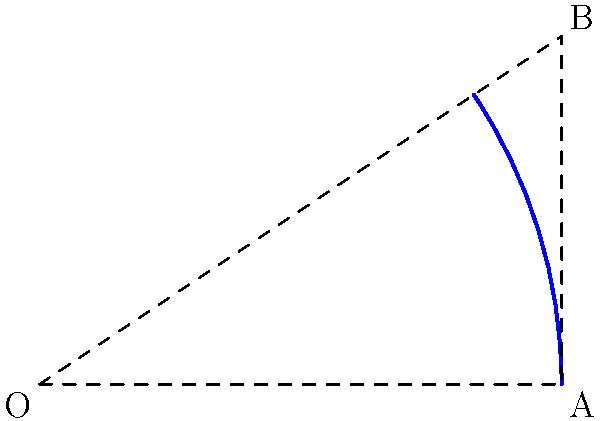A curved dental scaler has a radius of curvature of 3 cm. If the angle subtended by the arc at the center is $\theta = \tan^{-1}(\frac{2}{3})$ radians, what is the length of the curved part of the scaler? Round your answer to two decimal places. To find the length of the curved part of the dental scaler, we need to use the arc length formula:

$s = r\theta$

Where:
$s$ is the arc length
$r$ is the radius of curvature
$\theta$ is the angle subtended by the arc in radians

Given:
$r = 3$ cm
$\theta = \tan^{-1}(\frac{2}{3})$ radians

Steps:
1) First, let's calculate $\theta$:
   $\theta = \tan^{-1}(\frac{2}{3}) \approx 0.5880$ radians

2) Now, we can substitute the values into the arc length formula:
   $s = r\theta$
   $s = 3 \times 0.5880$
   $s \approx 1.7640$ cm

3) Rounding to two decimal places:
   $s \approx 1.76$ cm

Therefore, the length of the curved part of the dental scaler is approximately 1.76 cm.
Answer: 1.76 cm 